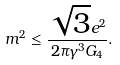<formula> <loc_0><loc_0><loc_500><loc_500>m ^ { 2 } \leq \frac { \sqrt { 3 } e ^ { 2 } } { 2 \pi \gamma ^ { 3 } G _ { 4 } } .</formula> 